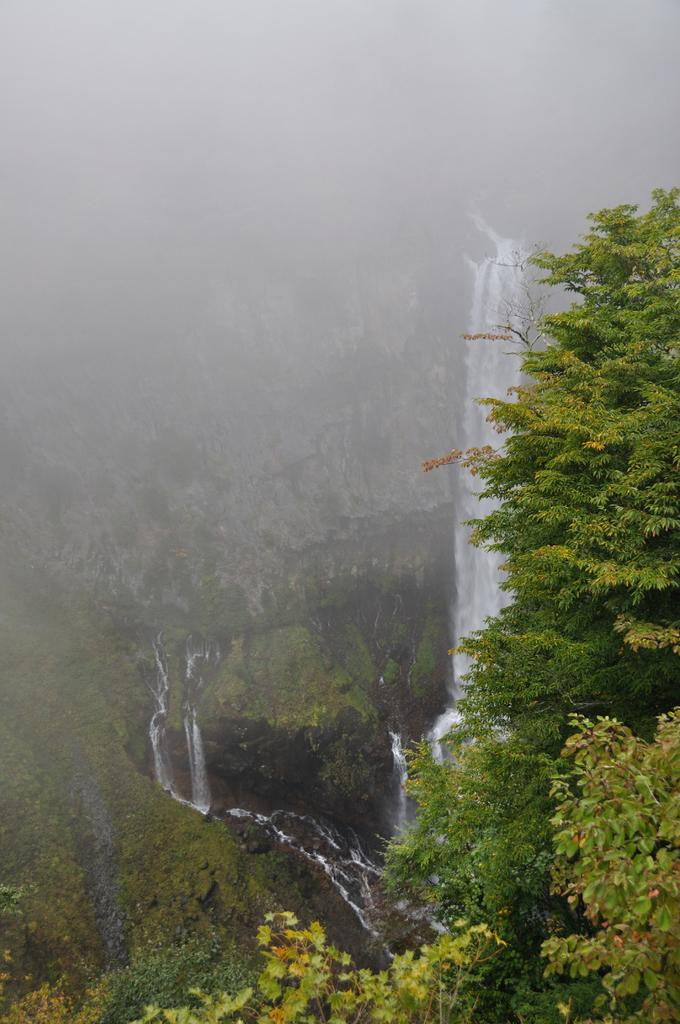What natural feature can be seen in the background of the image? There is a waterfall in the background of the image. What other geographical feature is visible in the background? There are mountains in the background of the image. What type of vegetation is present in the foreground of the image? There are trees in the foreground of the image. How much soap is being used by the girl in the image? There is no girl present in the image, and therefore no soap usage can be observed. What is the rate of water flow in the waterfall in the image? The rate of water flow in the waterfall cannot be determined from the image alone. 